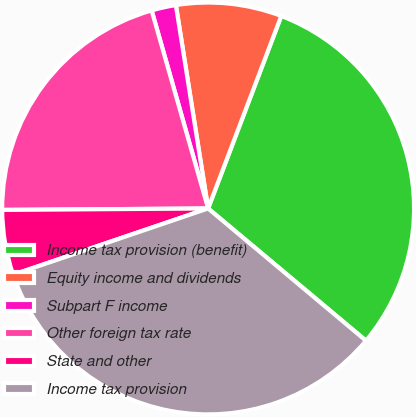<chart> <loc_0><loc_0><loc_500><loc_500><pie_chart><fcel>Income tax provision (benefit)<fcel>Equity income and dividends<fcel>Subpart F income<fcel>Other foreign tax rate<fcel>State and other<fcel>Income tax provision<nl><fcel>30.32%<fcel>8.28%<fcel>1.92%<fcel>20.69%<fcel>5.1%<fcel>33.69%<nl></chart> 